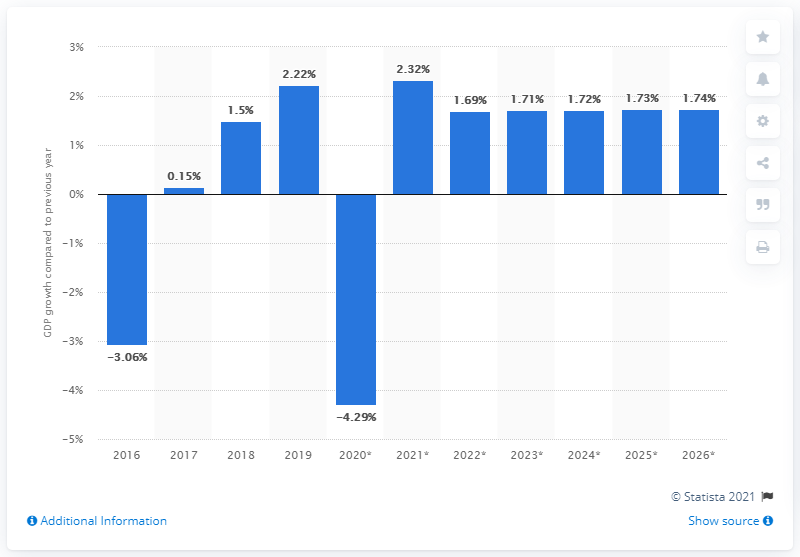Mention a couple of crucial points in this snapshot. Azerbaijan's real GDP increased by 2.22% in 2019. 